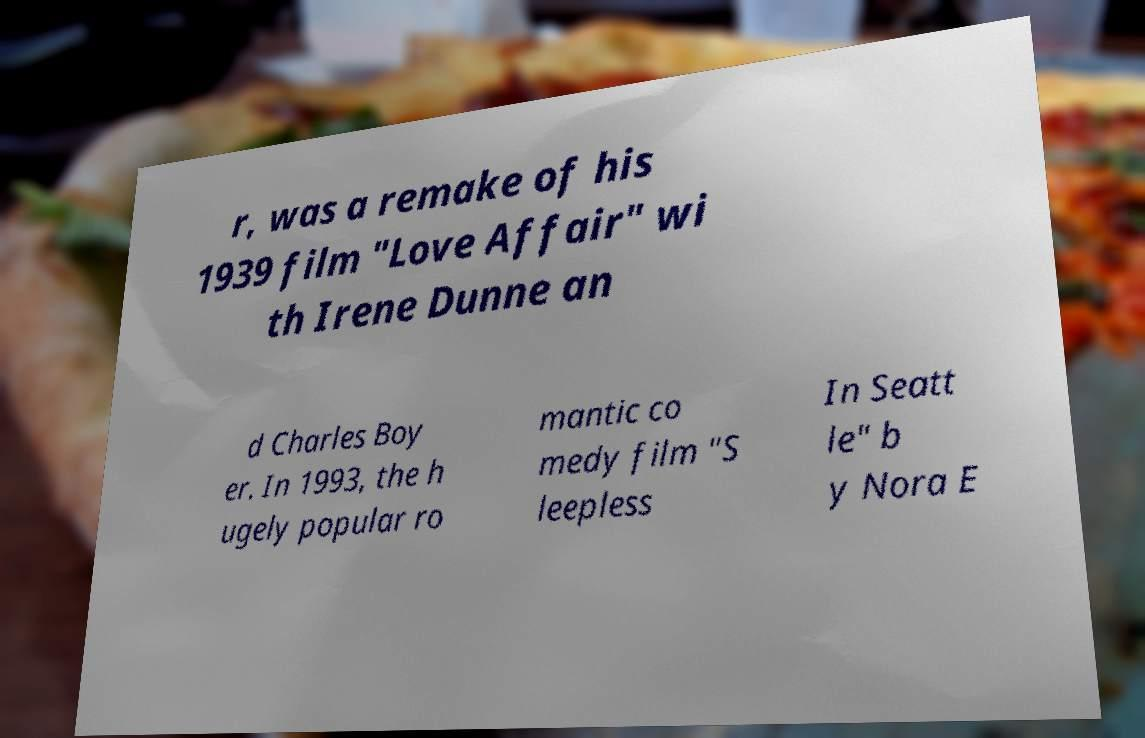There's text embedded in this image that I need extracted. Can you transcribe it verbatim? r, was a remake of his 1939 film "Love Affair" wi th Irene Dunne an d Charles Boy er. In 1993, the h ugely popular ro mantic co medy film "S leepless In Seatt le" b y Nora E 